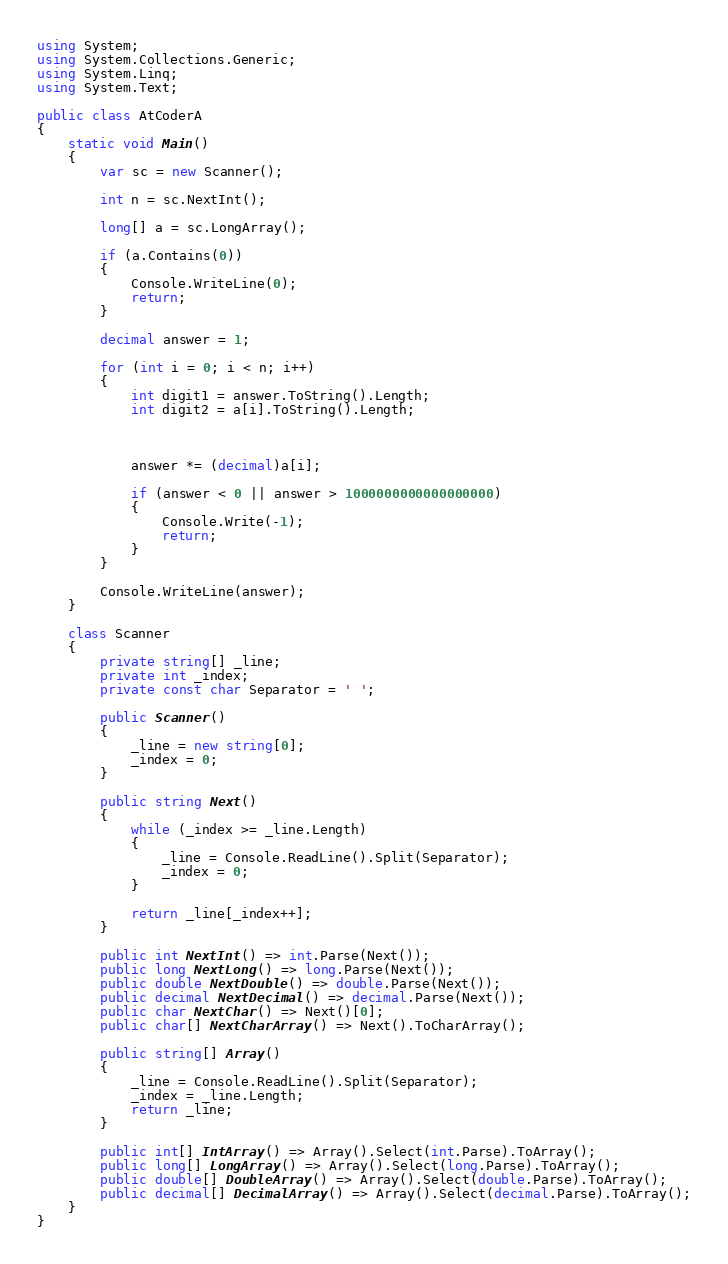Convert code to text. <code><loc_0><loc_0><loc_500><loc_500><_C#_>using System;
using System.Collections.Generic;
using System.Linq;
using System.Text;

public class AtCoderA
{
    static void Main()
    {
        var sc = new Scanner();

        int n = sc.NextInt();

        long[] a = sc.LongArray();

        if (a.Contains(0))
        {
            Console.WriteLine(0);
            return;
        }

        decimal answer = 1;

        for (int i = 0; i < n; i++)
        {
            int digit1 = answer.ToString().Length;
            int digit2 = a[i].ToString().Length;



            answer *= (decimal)a[i];

            if (answer < 0 || answer > 1000000000000000000)
            {
                Console.Write(-1);
                return;
            }
        }

        Console.WriteLine(answer);
    }

    class Scanner
    {
        private string[] _line;
        private int _index;
        private const char Separator = ' ';

        public Scanner()
        {
            _line = new string[0];
            _index = 0;
        }

        public string Next()
        {
            while (_index >= _line.Length)
            {
                _line = Console.ReadLine().Split(Separator);
                _index = 0;
            }

            return _line[_index++];
        }

        public int NextInt() => int.Parse(Next());
        public long NextLong() => long.Parse(Next());
        public double NextDouble() => double.Parse(Next());
        public decimal NextDecimal() => decimal.Parse(Next());
        public char NextChar() => Next()[0];
        public char[] NextCharArray() => Next().ToCharArray();

        public string[] Array()
        {
            _line = Console.ReadLine().Split(Separator);
            _index = _line.Length;
            return _line;
        }

        public int[] IntArray() => Array().Select(int.Parse).ToArray();
        public long[] LongArray() => Array().Select(long.Parse).ToArray();
        public double[] DoubleArray() => Array().Select(double.Parse).ToArray();
        public decimal[] DecimalArray() => Array().Select(decimal.Parse).ToArray();
    }
}</code> 